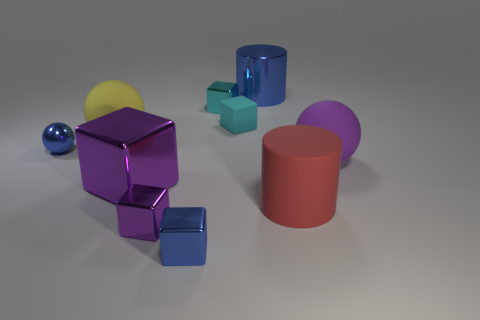Subtract all purple blocks. How many were subtracted if there are1purple blocks left? 1 Subtract all blue cubes. How many cubes are left? 4 Subtract all cyan matte blocks. How many blocks are left? 4 Subtract all brown cubes. Subtract all purple balls. How many cubes are left? 5 Subtract all spheres. How many objects are left? 7 Add 1 gray rubber cubes. How many gray rubber cubes exist? 1 Subtract 0 brown balls. How many objects are left? 10 Subtract all tiny purple shiny objects. Subtract all balls. How many objects are left? 6 Add 7 tiny purple shiny cubes. How many tiny purple shiny cubes are left? 8 